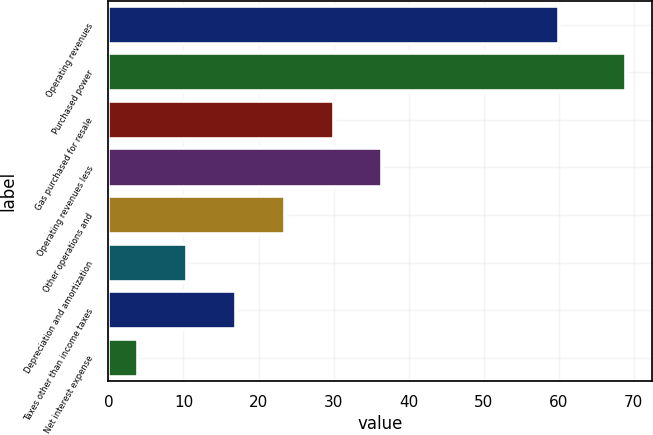Convert chart to OTSL. <chart><loc_0><loc_0><loc_500><loc_500><bar_chart><fcel>Operating revenues<fcel>Purchased power<fcel>Gas purchased for resale<fcel>Operating revenues less<fcel>Other operations and<fcel>Depreciation and amortization<fcel>Taxes other than income taxes<fcel>Net interest expense<nl><fcel>60<fcel>69<fcel>30<fcel>36.5<fcel>23.5<fcel>10.5<fcel>17<fcel>4<nl></chart> 